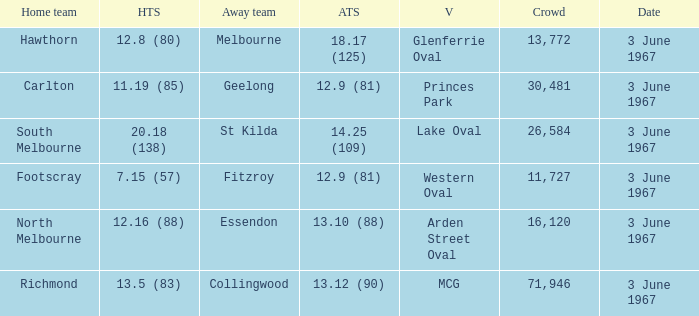Where did Geelong play as the away team? Princes Park. 